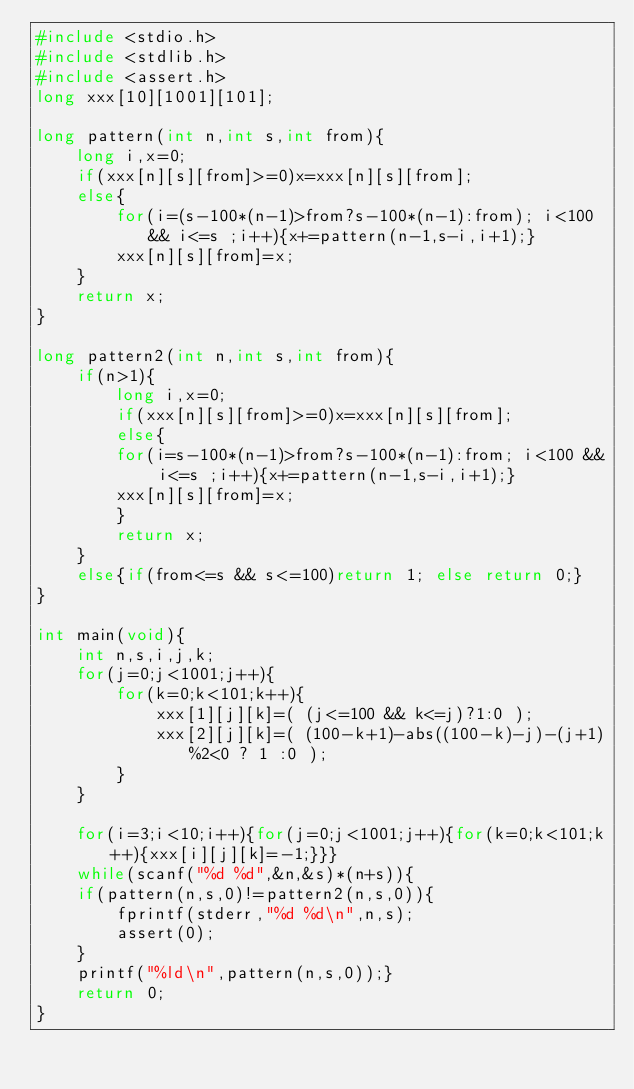<code> <loc_0><loc_0><loc_500><loc_500><_C_>#include <stdio.h>
#include <stdlib.h>
#include <assert.h>
long xxx[10][1001][101];

long pattern(int n,int s,int from){
	long i,x=0;
	if(xxx[n][s][from]>=0)x=xxx[n][s][from];
	else{
		for(i=(s-100*(n-1)>from?s-100*(n-1):from); i<100 && i<=s ;i++){x+=pattern(n-1,s-i,i+1);}
		xxx[n][s][from]=x;
	}
	return x;
}

long pattern2(int n,int s,int from){
    if(n>1){
        long i,x=0;
        if(xxx[n][s][from]>=0)x=xxx[n][s][from];
        else{
        for(i=s-100*(n-1)>from?s-100*(n-1):from; i<100 && i<=s ;i++){x+=pattern(n-1,s-i,i+1);}
        xxx[n][s][from]=x;
        }
        return x;
    }
    else{if(from<=s && s<=100)return 1; else return 0;}
}

int main(void){
	int n,s,i,j,k;
	for(j=0;j<1001;j++){
		for(k=0;k<101;k++){
			xxx[1][j][k]=( (j<=100 && k<=j)?1:0 );
			xxx[2][j][k]=( (100-k+1)-abs((100-k)-j)-(j+1)%2<0 ? 1 :0 );
		}
	}

	for(i=3;i<10;i++){for(j=0;j<1001;j++){for(k=0;k<101;k++){xxx[i][j][k]=-1;}}}
    while(scanf("%d %d",&n,&s)*(n+s)){
	if(pattern(n,s,0)!=pattern2(n,s,0)){
		fprintf(stderr,"%d %d\n",n,s);
		assert(0);
	}
	printf("%ld\n",pattern(n,s,0));}
    return 0;
}</code> 